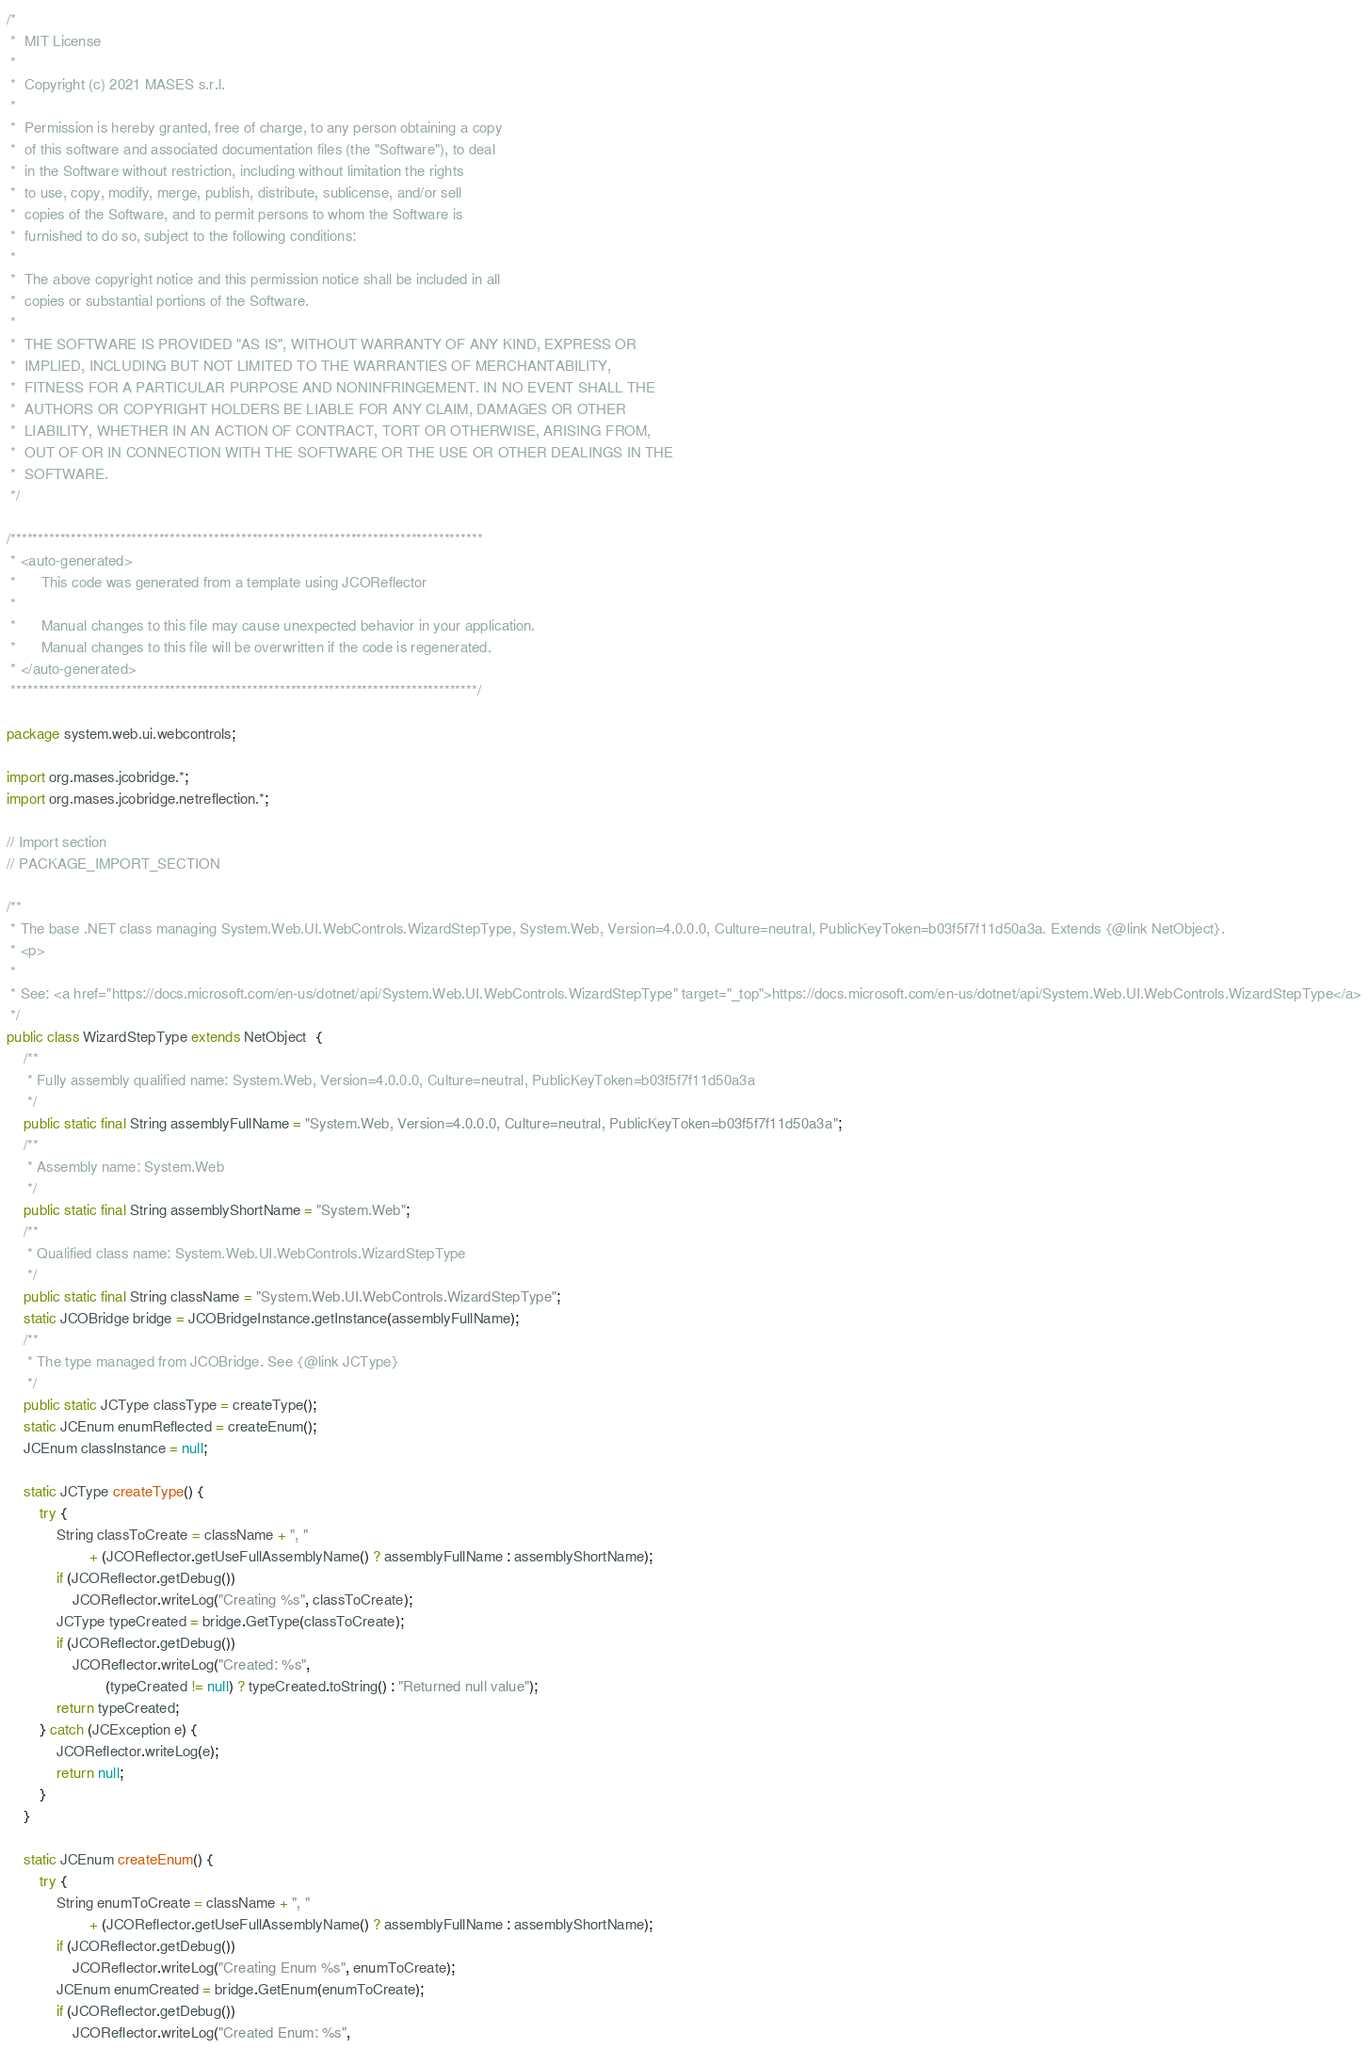<code> <loc_0><loc_0><loc_500><loc_500><_Java_>/*
 *  MIT License
 *
 *  Copyright (c) 2021 MASES s.r.l.
 *
 *  Permission is hereby granted, free of charge, to any person obtaining a copy
 *  of this software and associated documentation files (the "Software"), to deal
 *  in the Software without restriction, including without limitation the rights
 *  to use, copy, modify, merge, publish, distribute, sublicense, and/or sell
 *  copies of the Software, and to permit persons to whom the Software is
 *  furnished to do so, subject to the following conditions:
 *
 *  The above copyright notice and this permission notice shall be included in all
 *  copies or substantial portions of the Software.
 *
 *  THE SOFTWARE IS PROVIDED "AS IS", WITHOUT WARRANTY OF ANY KIND, EXPRESS OR
 *  IMPLIED, INCLUDING BUT NOT LIMITED TO THE WARRANTIES OF MERCHANTABILITY,
 *  FITNESS FOR A PARTICULAR PURPOSE AND NONINFRINGEMENT. IN NO EVENT SHALL THE
 *  AUTHORS OR COPYRIGHT HOLDERS BE LIABLE FOR ANY CLAIM, DAMAGES OR OTHER
 *  LIABILITY, WHETHER IN AN ACTION OF CONTRACT, TORT OR OTHERWISE, ARISING FROM,
 *  OUT OF OR IN CONNECTION WITH THE SOFTWARE OR THE USE OR OTHER DEALINGS IN THE
 *  SOFTWARE.
 */

/**************************************************************************************
 * <auto-generated>
 *      This code was generated from a template using JCOReflector
 * 
 *      Manual changes to this file may cause unexpected behavior in your application.
 *      Manual changes to this file will be overwritten if the code is regenerated.
 * </auto-generated>
 *************************************************************************************/

package system.web.ui.webcontrols;

import org.mases.jcobridge.*;
import org.mases.jcobridge.netreflection.*;

// Import section
// PACKAGE_IMPORT_SECTION

/**
 * The base .NET class managing System.Web.UI.WebControls.WizardStepType, System.Web, Version=4.0.0.0, Culture=neutral, PublicKeyToken=b03f5f7f11d50a3a. Extends {@link NetObject}.
 * <p>
 * 
 * See: <a href="https://docs.microsoft.com/en-us/dotnet/api/System.Web.UI.WebControls.WizardStepType" target="_top">https://docs.microsoft.com/en-us/dotnet/api/System.Web.UI.WebControls.WizardStepType</a>
 */
public class WizardStepType extends NetObject  {
    /**
     * Fully assembly qualified name: System.Web, Version=4.0.0.0, Culture=neutral, PublicKeyToken=b03f5f7f11d50a3a
     */
    public static final String assemblyFullName = "System.Web, Version=4.0.0.0, Culture=neutral, PublicKeyToken=b03f5f7f11d50a3a";
    /**
     * Assembly name: System.Web
     */
    public static final String assemblyShortName = "System.Web";
    /**
     * Qualified class name: System.Web.UI.WebControls.WizardStepType
     */
    public static final String className = "System.Web.UI.WebControls.WizardStepType";
    static JCOBridge bridge = JCOBridgeInstance.getInstance(assemblyFullName);
    /**
     * The type managed from JCOBridge. See {@link JCType}
     */
    public static JCType classType = createType();
    static JCEnum enumReflected = createEnum();
    JCEnum classInstance = null;

    static JCType createType() {
        try {
            String classToCreate = className + ", "
                    + (JCOReflector.getUseFullAssemblyName() ? assemblyFullName : assemblyShortName);
            if (JCOReflector.getDebug())
                JCOReflector.writeLog("Creating %s", classToCreate);
            JCType typeCreated = bridge.GetType(classToCreate);
            if (JCOReflector.getDebug())
                JCOReflector.writeLog("Created: %s",
                        (typeCreated != null) ? typeCreated.toString() : "Returned null value");
            return typeCreated;
        } catch (JCException e) {
            JCOReflector.writeLog(e);
            return null;
        }
    }

    static JCEnum createEnum() {
        try {
            String enumToCreate = className + ", "
                    + (JCOReflector.getUseFullAssemblyName() ? assemblyFullName : assemblyShortName);
            if (JCOReflector.getDebug())
                JCOReflector.writeLog("Creating Enum %s", enumToCreate);
            JCEnum enumCreated = bridge.GetEnum(enumToCreate);
            if (JCOReflector.getDebug())
                JCOReflector.writeLog("Created Enum: %s",</code> 